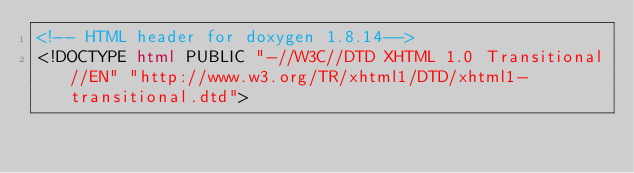<code> <loc_0><loc_0><loc_500><loc_500><_HTML_><!-- HTML header for doxygen 1.8.14-->
<!DOCTYPE html PUBLIC "-//W3C//DTD XHTML 1.0 Transitional//EN" "http://www.w3.org/TR/xhtml1/DTD/xhtml1-transitional.dtd"></code> 